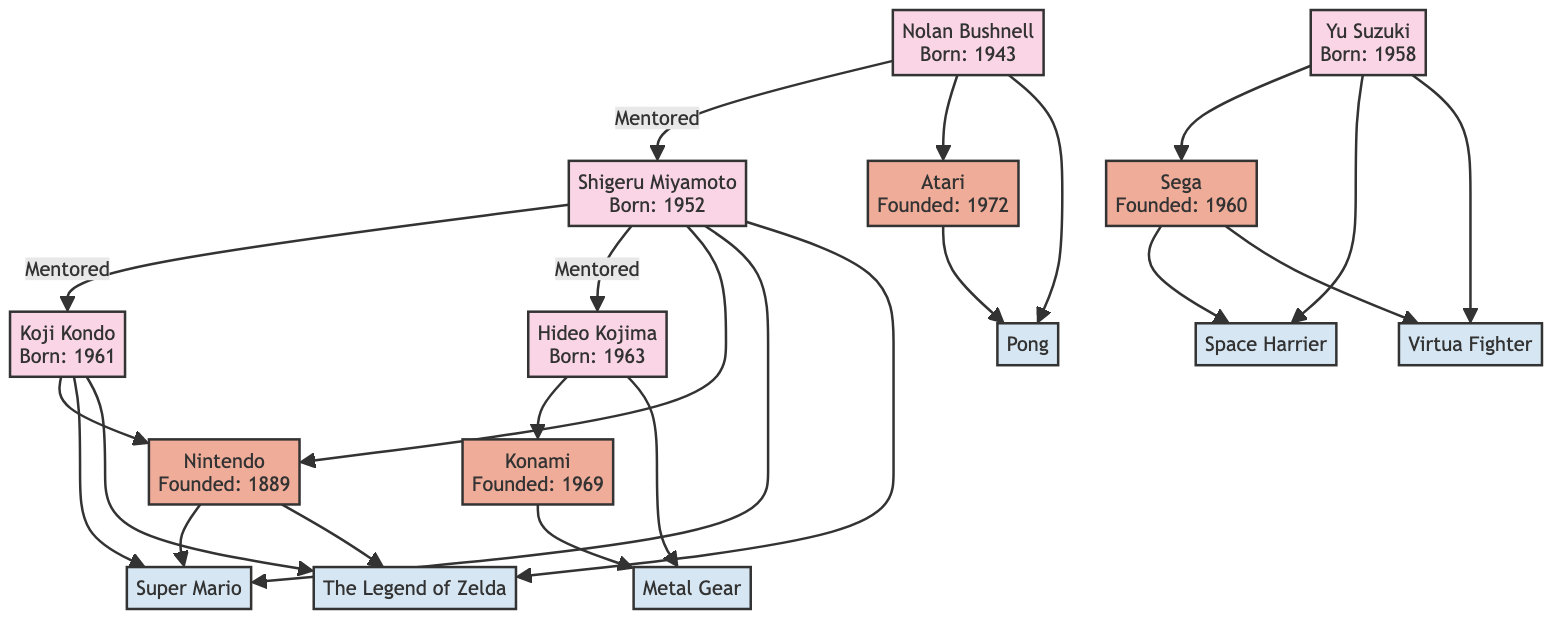What is the birth year of Shigeru Miyamoto? The diagram states that Shigeru Miyamoto was born in 1952, which is directly labeled next to his name.
Answer: 1952 Who mentored Hideo Kojima? Hideo Kojima is directly linked to Shigeru Miyamoto with a "Mentored" relationship, indicating that Miyamoto was his mentor.
Answer: Shigeru Miyamoto Which company was founded in 1969? The diagram lists Konami with the founding year noted as 1969. This is clearly indicated in the node for Konami.
Answer: Konami What notable game is attributed to Nolan Bushnell? The node for Nolan Bushnell shows that he is associated with the game "Pong," which is explicitly mentioned under his notable works.
Answer: Pong How many individuals are listed in the diagram? By counting the individual nodes (Shigeru Miyamoto, Hideo Kojima, Nolan Bushnell, Koji Kondo, Yu Suzuki), there are a total of 5 individuals represented in the diagram.
Answer: 5 Which individual mentored Yu Suzuki? The diagram indicates that Yu Suzuki's mentor is not explicitly mentioned; thus, it should be noted that he does not have a mentor noted in the tree.
Answer: None Which company has Shigeru Miyamoto as a notable developer? The company Nintendo is shown as having Shigeru Miyamoto as one of its notable developers in the company portion of the diagram.
Answer: Nintendo What are the key games associated with the company Sega? The key games listed under the Sega company node are "Space Harrier" and "Virtua Fighter," clearly indicated in the section labeled for Sega.
Answer: Space Harrier, Virtua Fighter How many games are linked to Koji Kondo? Two games (Super Mario and The Legend of Zelda) are connected to Koji Kondo, as evidenced through the lines linking him to these games in the diagram.
Answer: 2 